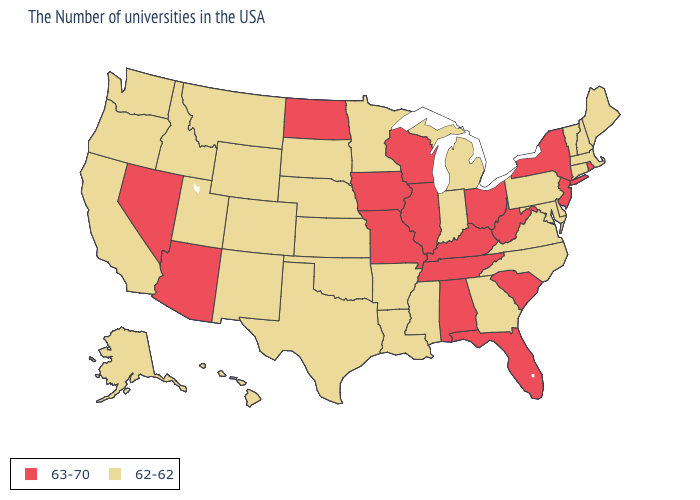Does New Jersey have the same value as Utah?
Answer briefly. No. What is the value of New York?
Be succinct. 63-70. Does Maine have the same value as Arkansas?
Answer briefly. Yes. Name the states that have a value in the range 62-62?
Be succinct. Maine, Massachusetts, New Hampshire, Vermont, Connecticut, Delaware, Maryland, Pennsylvania, Virginia, North Carolina, Georgia, Michigan, Indiana, Mississippi, Louisiana, Arkansas, Minnesota, Kansas, Nebraska, Oklahoma, Texas, South Dakota, Wyoming, Colorado, New Mexico, Utah, Montana, Idaho, California, Washington, Oregon, Alaska, Hawaii. Does the map have missing data?
Be succinct. No. What is the value of Louisiana?
Answer briefly. 62-62. Name the states that have a value in the range 62-62?
Quick response, please. Maine, Massachusetts, New Hampshire, Vermont, Connecticut, Delaware, Maryland, Pennsylvania, Virginia, North Carolina, Georgia, Michigan, Indiana, Mississippi, Louisiana, Arkansas, Minnesota, Kansas, Nebraska, Oklahoma, Texas, South Dakota, Wyoming, Colorado, New Mexico, Utah, Montana, Idaho, California, Washington, Oregon, Alaska, Hawaii. What is the lowest value in states that border Wyoming?
Quick response, please. 62-62. Name the states that have a value in the range 63-70?
Quick response, please. Rhode Island, New York, New Jersey, South Carolina, West Virginia, Ohio, Florida, Kentucky, Alabama, Tennessee, Wisconsin, Illinois, Missouri, Iowa, North Dakota, Arizona, Nevada. Which states have the highest value in the USA?
Give a very brief answer. Rhode Island, New York, New Jersey, South Carolina, West Virginia, Ohio, Florida, Kentucky, Alabama, Tennessee, Wisconsin, Illinois, Missouri, Iowa, North Dakota, Arizona, Nevada. What is the highest value in states that border Illinois?
Write a very short answer. 63-70. Does Nevada have the lowest value in the West?
Write a very short answer. No. Among the states that border Mississippi , which have the lowest value?
Keep it brief. Louisiana, Arkansas. Does Maine have the same value as Oklahoma?
Be succinct. Yes. What is the lowest value in the West?
Give a very brief answer. 62-62. 